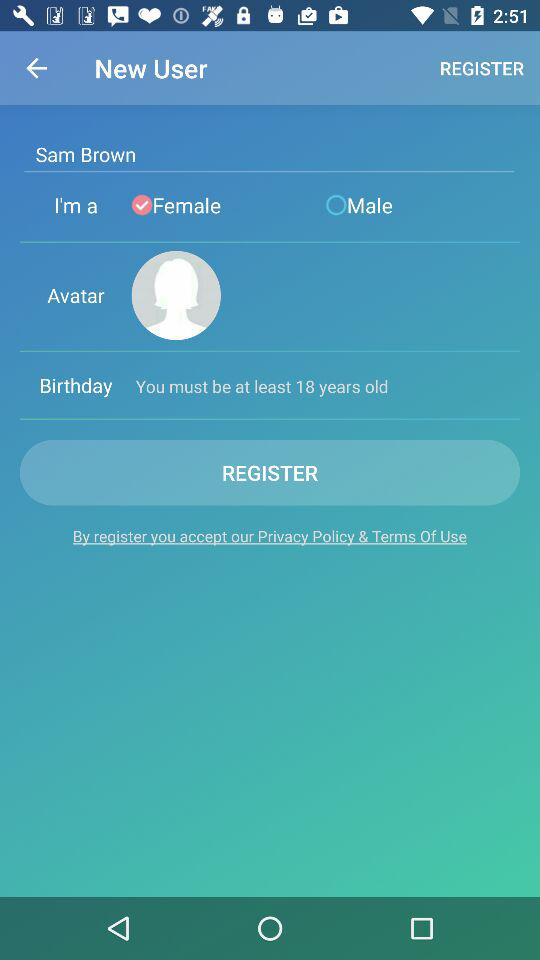What is the minimum age limit? The minimum age limit is 18 years. 